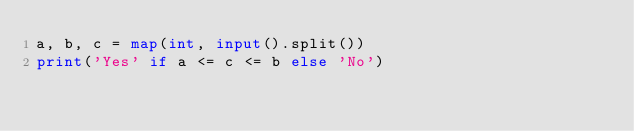<code> <loc_0><loc_0><loc_500><loc_500><_Python_>a, b, c = map(int, input().split())
print('Yes' if a <= c <= b else 'No')</code> 